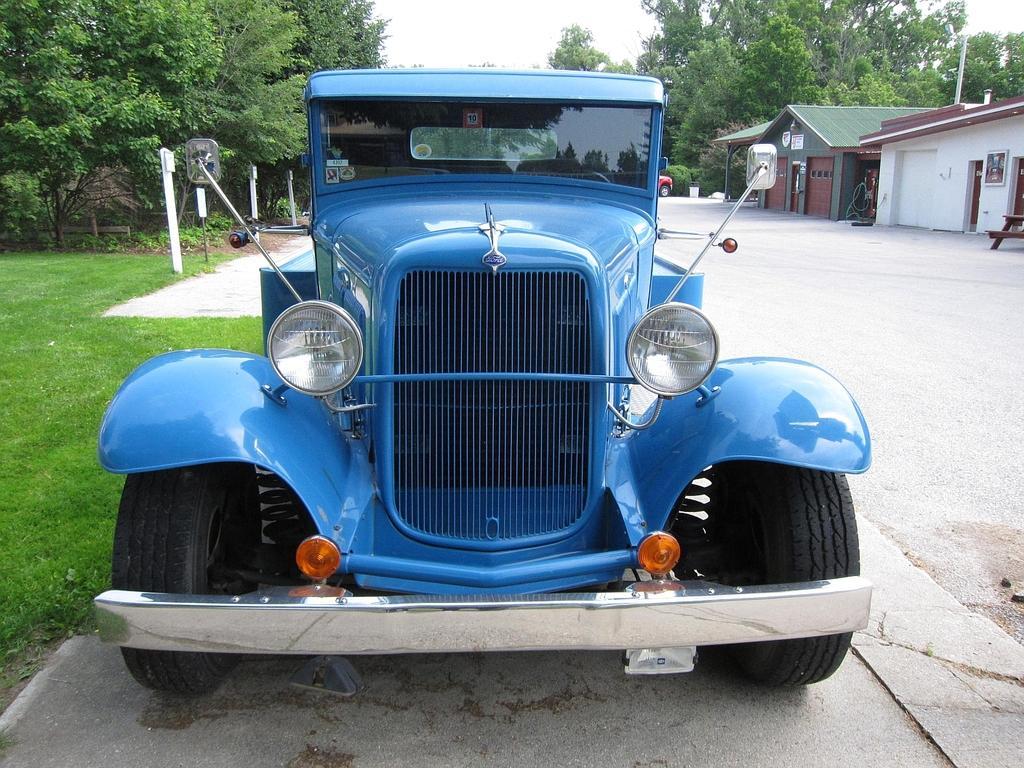Could you give a brief overview of what you see in this image? In this image we can see two houses, some objects are attached to the houses, one road, two vehicles and some objects are on the surface. There are some trees, plants, bushes and green grass on the ground. At the top there is the sky. 